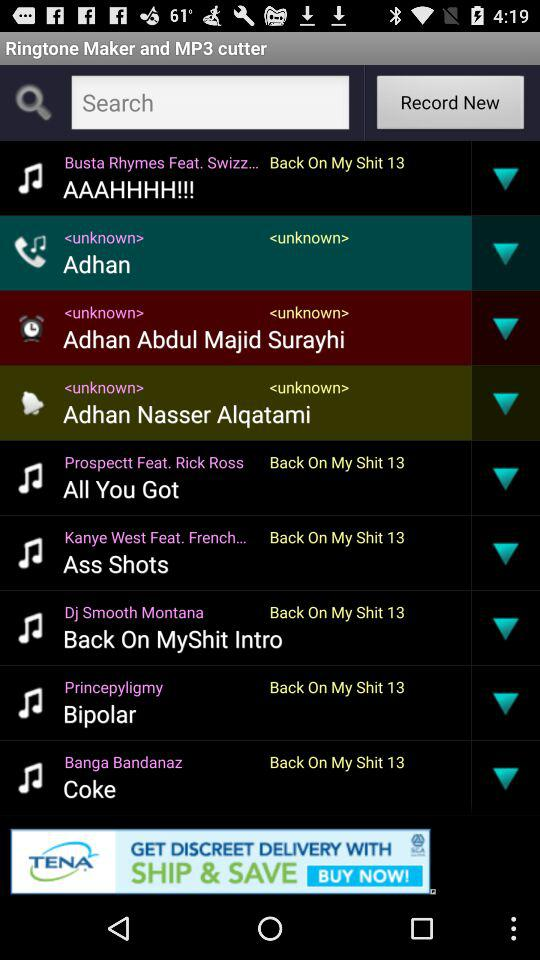What is the name of the ringtone created by Banga Bandanaz? The ringtone is "Coke". 